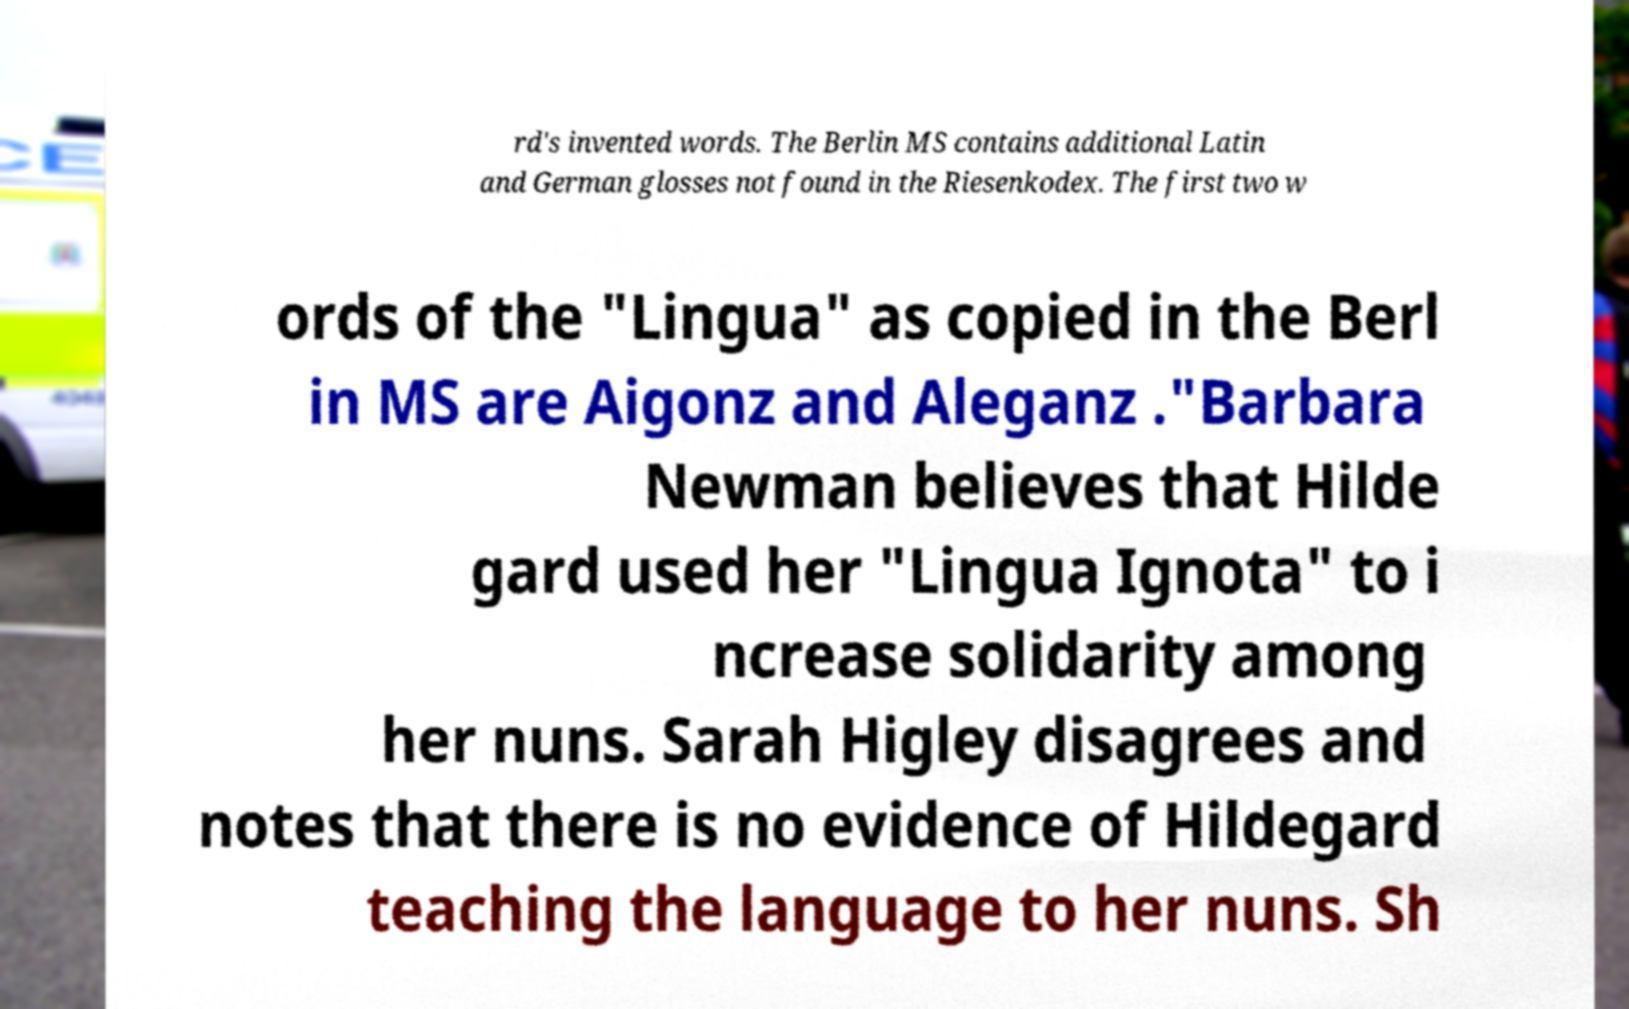Can you accurately transcribe the text from the provided image for me? rd's invented words. The Berlin MS contains additional Latin and German glosses not found in the Riesenkodex. The first two w ords of the "Lingua" as copied in the Berl in MS are Aigonz and Aleganz ."Barbara Newman believes that Hilde gard used her "Lingua Ignota" to i ncrease solidarity among her nuns. Sarah Higley disagrees and notes that there is no evidence of Hildegard teaching the language to her nuns. Sh 